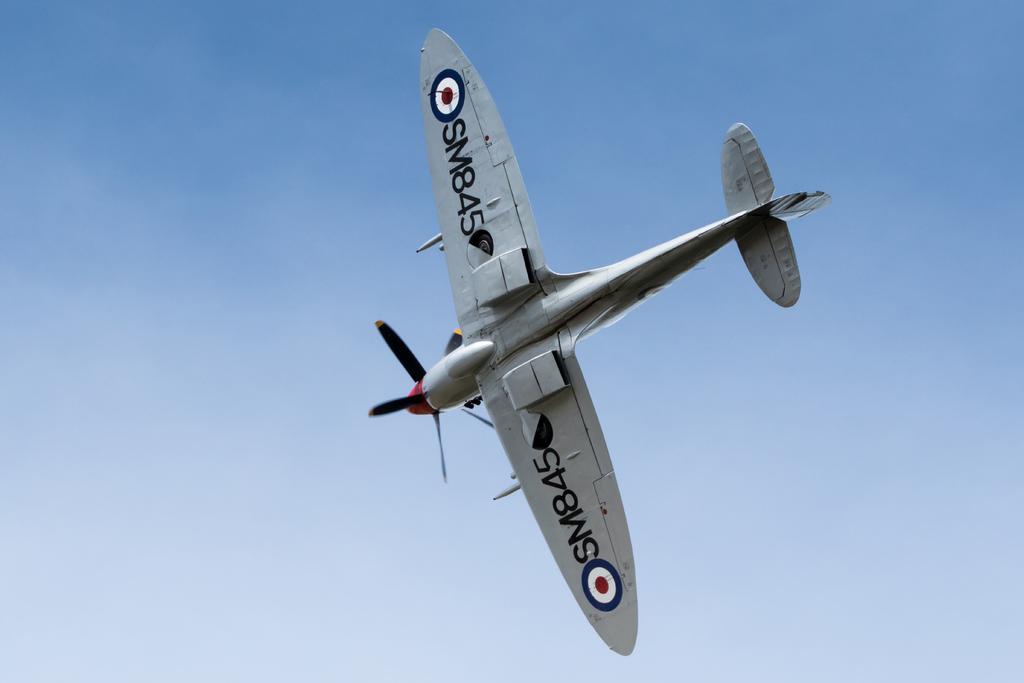What is the plane number?
Offer a terse response. Sm845. 